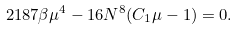<formula> <loc_0><loc_0><loc_500><loc_500>2 1 8 7 \beta \mu ^ { 4 } - 1 6 N ^ { 8 } ( C _ { 1 } \mu - 1 ) = 0 .</formula> 